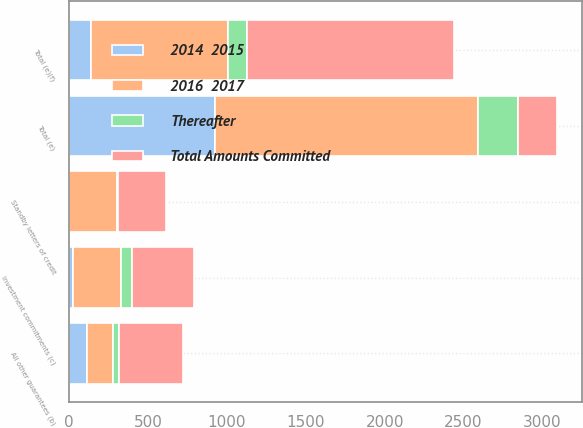Convert chart to OTSL. <chart><loc_0><loc_0><loc_500><loc_500><stacked_bar_chart><ecel><fcel>Total (e)<fcel>Standby letters of credit<fcel>All other guarantees (b)<fcel>Investment commitments (c)<fcel>Total (e)(f)<nl><fcel>Total Amounts Committed<fcel>252<fcel>307<fcel>407<fcel>396<fcel>1316<nl><fcel>2016  2017<fcel>1668<fcel>299<fcel>171<fcel>302<fcel>874<nl><fcel>Thereafter<fcel>252<fcel>6<fcel>35<fcel>70<fcel>117<nl><fcel>2014  2015<fcel>923<fcel>1<fcel>109<fcel>25<fcel>135<nl></chart> 